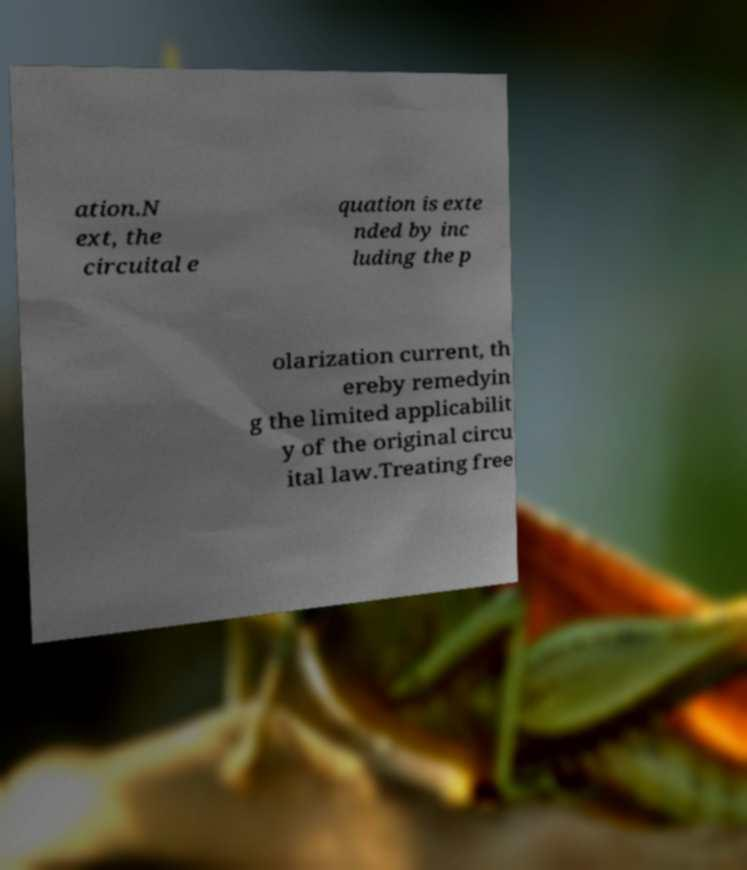Could you extract and type out the text from this image? ation.N ext, the circuital e quation is exte nded by inc luding the p olarization current, th ereby remedyin g the limited applicabilit y of the original circu ital law.Treating free 